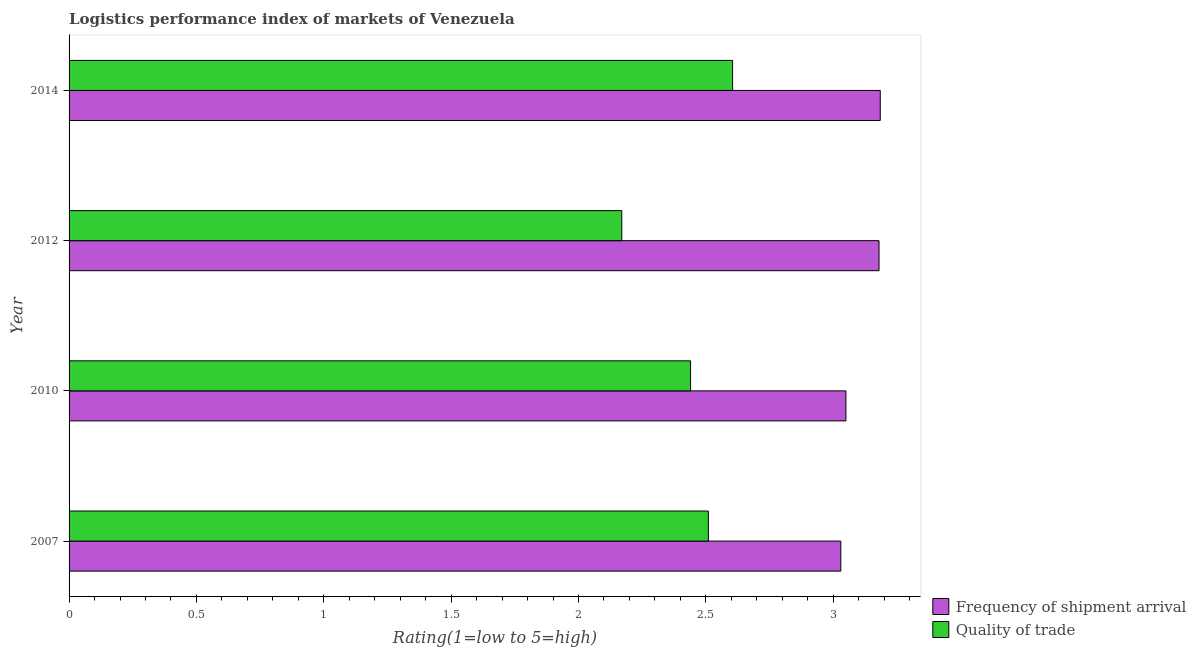How many groups of bars are there?
Give a very brief answer. 4. Are the number of bars on each tick of the Y-axis equal?
Ensure brevity in your answer.  Yes. In how many cases, is the number of bars for a given year not equal to the number of legend labels?
Offer a terse response. 0. What is the lpi quality of trade in 2014?
Provide a succinct answer. 2.61. Across all years, what is the maximum lpi quality of trade?
Offer a very short reply. 2.61. Across all years, what is the minimum lpi quality of trade?
Offer a very short reply. 2.17. In which year was the lpi quality of trade minimum?
Offer a terse response. 2012. What is the total lpi of frequency of shipment arrival in the graph?
Give a very brief answer. 12.44. What is the difference between the lpi quality of trade in 2010 and that in 2012?
Your response must be concise. 0.27. What is the difference between the lpi quality of trade in 2012 and the lpi of frequency of shipment arrival in 2007?
Keep it short and to the point. -0.86. What is the average lpi of frequency of shipment arrival per year?
Your response must be concise. 3.11. In the year 2012, what is the difference between the lpi of frequency of shipment arrival and lpi quality of trade?
Your response must be concise. 1.01. What is the ratio of the lpi of frequency of shipment arrival in 2010 to that in 2012?
Ensure brevity in your answer.  0.96. Is the lpi of frequency of shipment arrival in 2007 less than that in 2010?
Make the answer very short. Yes. Is the difference between the lpi of frequency of shipment arrival in 2010 and 2012 greater than the difference between the lpi quality of trade in 2010 and 2012?
Offer a very short reply. No. What is the difference between the highest and the second highest lpi quality of trade?
Your answer should be very brief. 0.1. What is the difference between the highest and the lowest lpi of frequency of shipment arrival?
Your response must be concise. 0.15. In how many years, is the lpi of frequency of shipment arrival greater than the average lpi of frequency of shipment arrival taken over all years?
Give a very brief answer. 2. Is the sum of the lpi quality of trade in 2010 and 2012 greater than the maximum lpi of frequency of shipment arrival across all years?
Offer a terse response. Yes. What does the 1st bar from the top in 2007 represents?
Provide a succinct answer. Quality of trade. What does the 1st bar from the bottom in 2010 represents?
Your answer should be very brief. Frequency of shipment arrival. How many years are there in the graph?
Keep it short and to the point. 4. What is the difference between two consecutive major ticks on the X-axis?
Give a very brief answer. 0.5. Are the values on the major ticks of X-axis written in scientific E-notation?
Make the answer very short. No. Does the graph contain grids?
Keep it short and to the point. No. How many legend labels are there?
Provide a succinct answer. 2. What is the title of the graph?
Provide a short and direct response. Logistics performance index of markets of Venezuela. Does "Urban" appear as one of the legend labels in the graph?
Offer a very short reply. No. What is the label or title of the X-axis?
Ensure brevity in your answer.  Rating(1=low to 5=high). What is the Rating(1=low to 5=high) of Frequency of shipment arrival in 2007?
Make the answer very short. 3.03. What is the Rating(1=low to 5=high) in Quality of trade in 2007?
Offer a terse response. 2.51. What is the Rating(1=low to 5=high) of Frequency of shipment arrival in 2010?
Keep it short and to the point. 3.05. What is the Rating(1=low to 5=high) in Quality of trade in 2010?
Provide a succinct answer. 2.44. What is the Rating(1=low to 5=high) in Frequency of shipment arrival in 2012?
Keep it short and to the point. 3.18. What is the Rating(1=low to 5=high) in Quality of trade in 2012?
Your answer should be very brief. 2.17. What is the Rating(1=low to 5=high) in Frequency of shipment arrival in 2014?
Offer a very short reply. 3.18. What is the Rating(1=low to 5=high) of Quality of trade in 2014?
Provide a short and direct response. 2.61. Across all years, what is the maximum Rating(1=low to 5=high) in Frequency of shipment arrival?
Your answer should be compact. 3.18. Across all years, what is the maximum Rating(1=low to 5=high) in Quality of trade?
Provide a succinct answer. 2.61. Across all years, what is the minimum Rating(1=low to 5=high) in Frequency of shipment arrival?
Give a very brief answer. 3.03. Across all years, what is the minimum Rating(1=low to 5=high) of Quality of trade?
Offer a terse response. 2.17. What is the total Rating(1=low to 5=high) of Frequency of shipment arrival in the graph?
Provide a succinct answer. 12.44. What is the total Rating(1=low to 5=high) of Quality of trade in the graph?
Make the answer very short. 9.73. What is the difference between the Rating(1=low to 5=high) in Frequency of shipment arrival in 2007 and that in 2010?
Offer a very short reply. -0.02. What is the difference between the Rating(1=low to 5=high) in Quality of trade in 2007 and that in 2010?
Ensure brevity in your answer.  0.07. What is the difference between the Rating(1=low to 5=high) of Quality of trade in 2007 and that in 2012?
Your response must be concise. 0.34. What is the difference between the Rating(1=low to 5=high) of Frequency of shipment arrival in 2007 and that in 2014?
Offer a very short reply. -0.15. What is the difference between the Rating(1=low to 5=high) in Quality of trade in 2007 and that in 2014?
Your answer should be compact. -0.1. What is the difference between the Rating(1=low to 5=high) in Frequency of shipment arrival in 2010 and that in 2012?
Your answer should be very brief. -0.13. What is the difference between the Rating(1=low to 5=high) of Quality of trade in 2010 and that in 2012?
Provide a succinct answer. 0.27. What is the difference between the Rating(1=low to 5=high) of Frequency of shipment arrival in 2010 and that in 2014?
Ensure brevity in your answer.  -0.13. What is the difference between the Rating(1=low to 5=high) of Quality of trade in 2010 and that in 2014?
Your response must be concise. -0.17. What is the difference between the Rating(1=low to 5=high) of Frequency of shipment arrival in 2012 and that in 2014?
Give a very brief answer. -0. What is the difference between the Rating(1=low to 5=high) in Quality of trade in 2012 and that in 2014?
Provide a short and direct response. -0.44. What is the difference between the Rating(1=low to 5=high) of Frequency of shipment arrival in 2007 and the Rating(1=low to 5=high) of Quality of trade in 2010?
Provide a succinct answer. 0.59. What is the difference between the Rating(1=low to 5=high) of Frequency of shipment arrival in 2007 and the Rating(1=low to 5=high) of Quality of trade in 2012?
Provide a succinct answer. 0.86. What is the difference between the Rating(1=low to 5=high) of Frequency of shipment arrival in 2007 and the Rating(1=low to 5=high) of Quality of trade in 2014?
Your answer should be compact. 0.42. What is the difference between the Rating(1=low to 5=high) in Frequency of shipment arrival in 2010 and the Rating(1=low to 5=high) in Quality of trade in 2014?
Offer a very short reply. 0.44. What is the difference between the Rating(1=low to 5=high) of Frequency of shipment arrival in 2012 and the Rating(1=low to 5=high) of Quality of trade in 2014?
Your answer should be very brief. 0.57. What is the average Rating(1=low to 5=high) of Frequency of shipment arrival per year?
Your response must be concise. 3.11. What is the average Rating(1=low to 5=high) of Quality of trade per year?
Offer a very short reply. 2.43. In the year 2007, what is the difference between the Rating(1=low to 5=high) in Frequency of shipment arrival and Rating(1=low to 5=high) in Quality of trade?
Your answer should be compact. 0.52. In the year 2010, what is the difference between the Rating(1=low to 5=high) of Frequency of shipment arrival and Rating(1=low to 5=high) of Quality of trade?
Keep it short and to the point. 0.61. In the year 2014, what is the difference between the Rating(1=low to 5=high) in Frequency of shipment arrival and Rating(1=low to 5=high) in Quality of trade?
Offer a very short reply. 0.58. What is the ratio of the Rating(1=low to 5=high) of Frequency of shipment arrival in 2007 to that in 2010?
Your response must be concise. 0.99. What is the ratio of the Rating(1=low to 5=high) in Quality of trade in 2007 to that in 2010?
Offer a terse response. 1.03. What is the ratio of the Rating(1=low to 5=high) of Frequency of shipment arrival in 2007 to that in 2012?
Your response must be concise. 0.95. What is the ratio of the Rating(1=low to 5=high) in Quality of trade in 2007 to that in 2012?
Offer a terse response. 1.16. What is the ratio of the Rating(1=low to 5=high) in Frequency of shipment arrival in 2007 to that in 2014?
Your response must be concise. 0.95. What is the ratio of the Rating(1=low to 5=high) in Quality of trade in 2007 to that in 2014?
Make the answer very short. 0.96. What is the ratio of the Rating(1=low to 5=high) in Frequency of shipment arrival in 2010 to that in 2012?
Make the answer very short. 0.96. What is the ratio of the Rating(1=low to 5=high) of Quality of trade in 2010 to that in 2012?
Offer a terse response. 1.12. What is the ratio of the Rating(1=low to 5=high) of Frequency of shipment arrival in 2010 to that in 2014?
Offer a very short reply. 0.96. What is the ratio of the Rating(1=low to 5=high) of Quality of trade in 2010 to that in 2014?
Your answer should be compact. 0.94. What is the ratio of the Rating(1=low to 5=high) in Frequency of shipment arrival in 2012 to that in 2014?
Your response must be concise. 1. What is the ratio of the Rating(1=low to 5=high) of Quality of trade in 2012 to that in 2014?
Offer a very short reply. 0.83. What is the difference between the highest and the second highest Rating(1=low to 5=high) of Frequency of shipment arrival?
Keep it short and to the point. 0. What is the difference between the highest and the second highest Rating(1=low to 5=high) of Quality of trade?
Provide a short and direct response. 0.1. What is the difference between the highest and the lowest Rating(1=low to 5=high) of Frequency of shipment arrival?
Make the answer very short. 0.15. What is the difference between the highest and the lowest Rating(1=low to 5=high) of Quality of trade?
Offer a terse response. 0.44. 